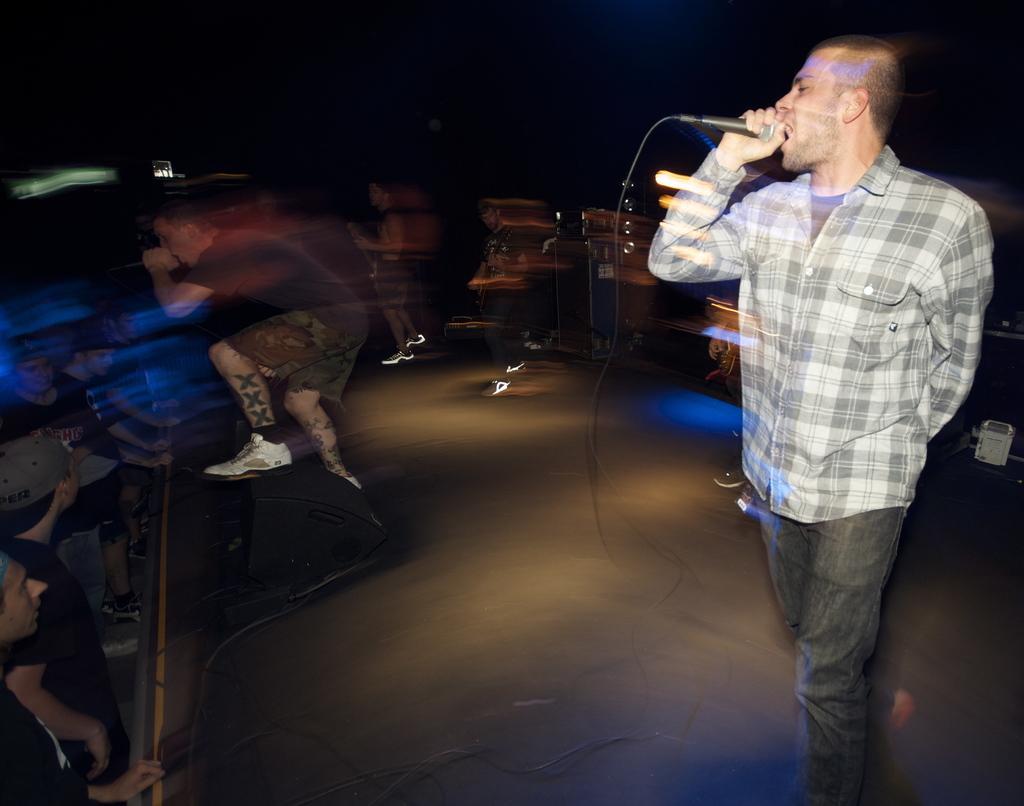How would you summarize this image in a sentence or two? This is a concert. A man at the right side holding a microphone and singing a song and a man at left side dancing holding a microphone and at the left bottom there are spectators and at the back side of the image there are men playing a musical instruments. 